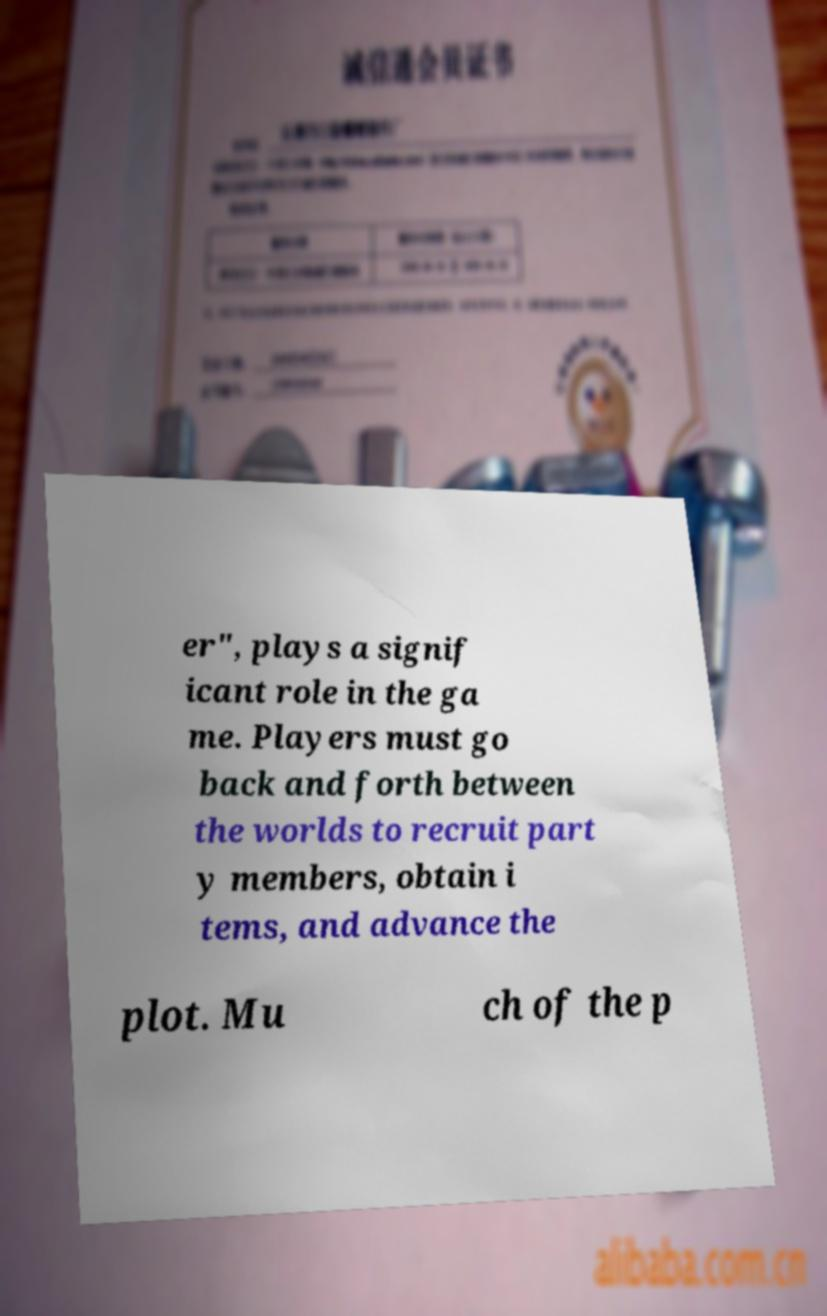There's text embedded in this image that I need extracted. Can you transcribe it verbatim? er", plays a signif icant role in the ga me. Players must go back and forth between the worlds to recruit part y members, obtain i tems, and advance the plot. Mu ch of the p 